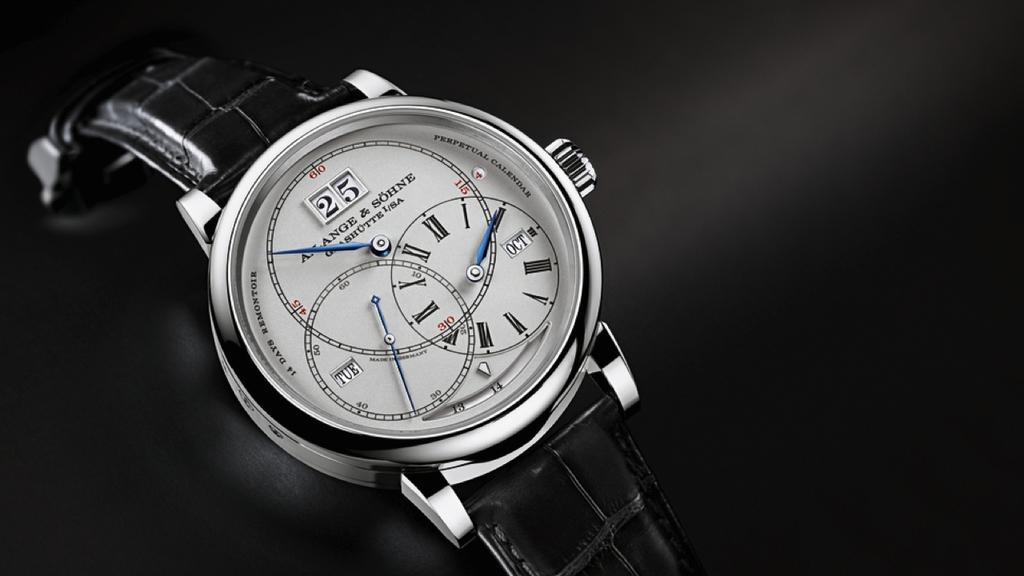<image>
Summarize the visual content of the image. Face of a watch which says Alange & Sohne on the face. 